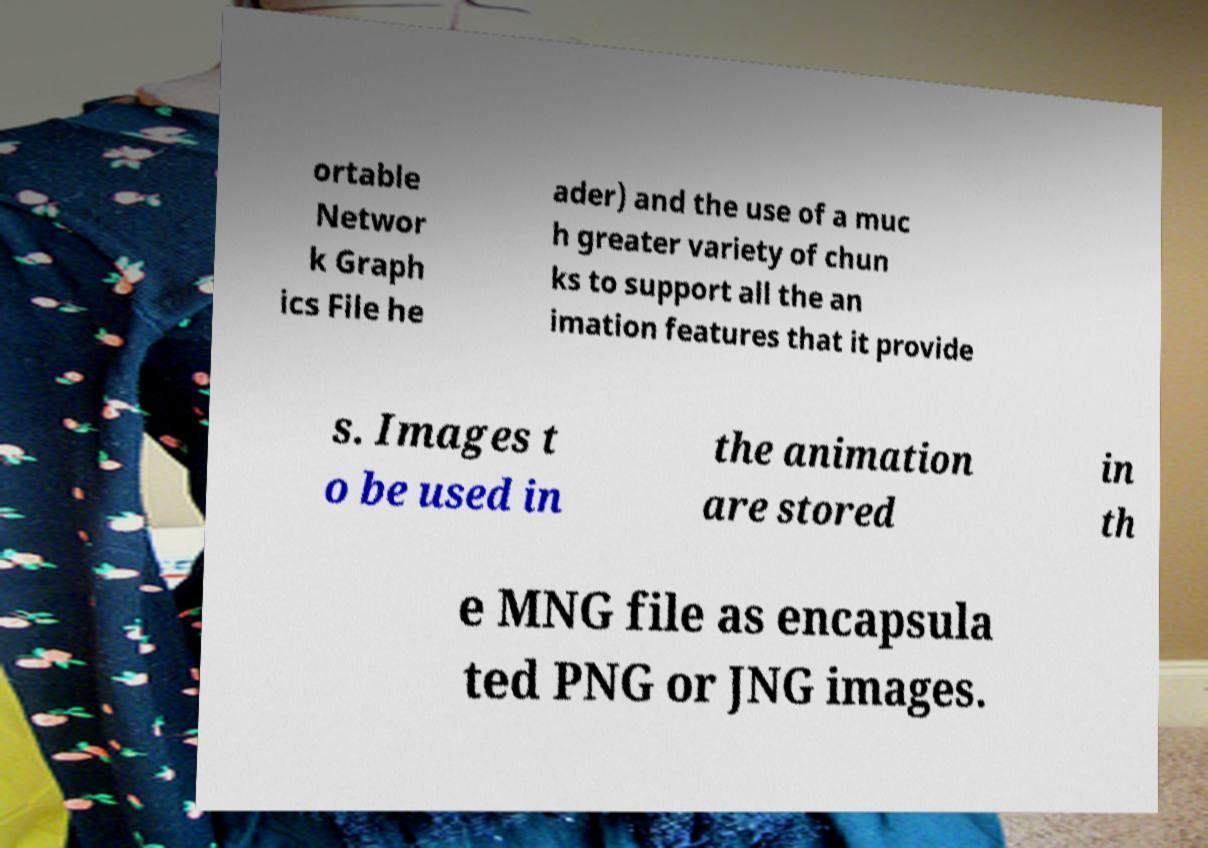Could you assist in decoding the text presented in this image and type it out clearly? ortable Networ k Graph ics File he ader) and the use of a muc h greater variety of chun ks to support all the an imation features that it provide s. Images t o be used in the animation are stored in th e MNG file as encapsula ted PNG or JNG images. 